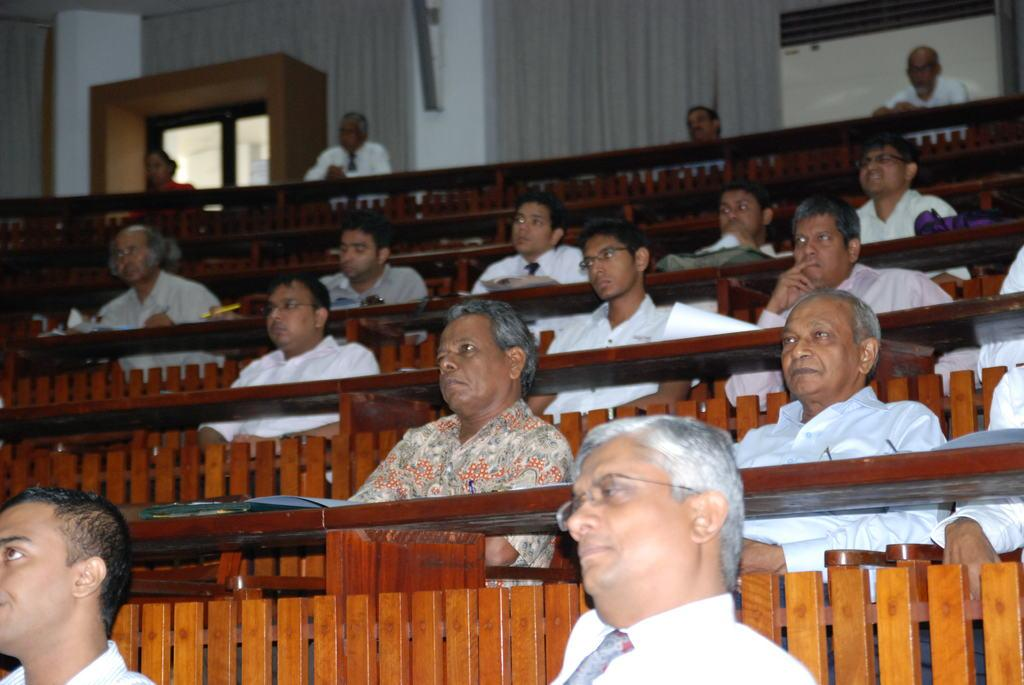What are the people in the image doing? The people are sitting in the image. Where are the people sitting? The people are sitting in front of desks. What can be seen in the background of the image? There are curtains in the background of the image. What type of silk is draped over the desks in the image? There is no silk present in the image; the people are sitting in front of desks, and there are curtains in the background. 